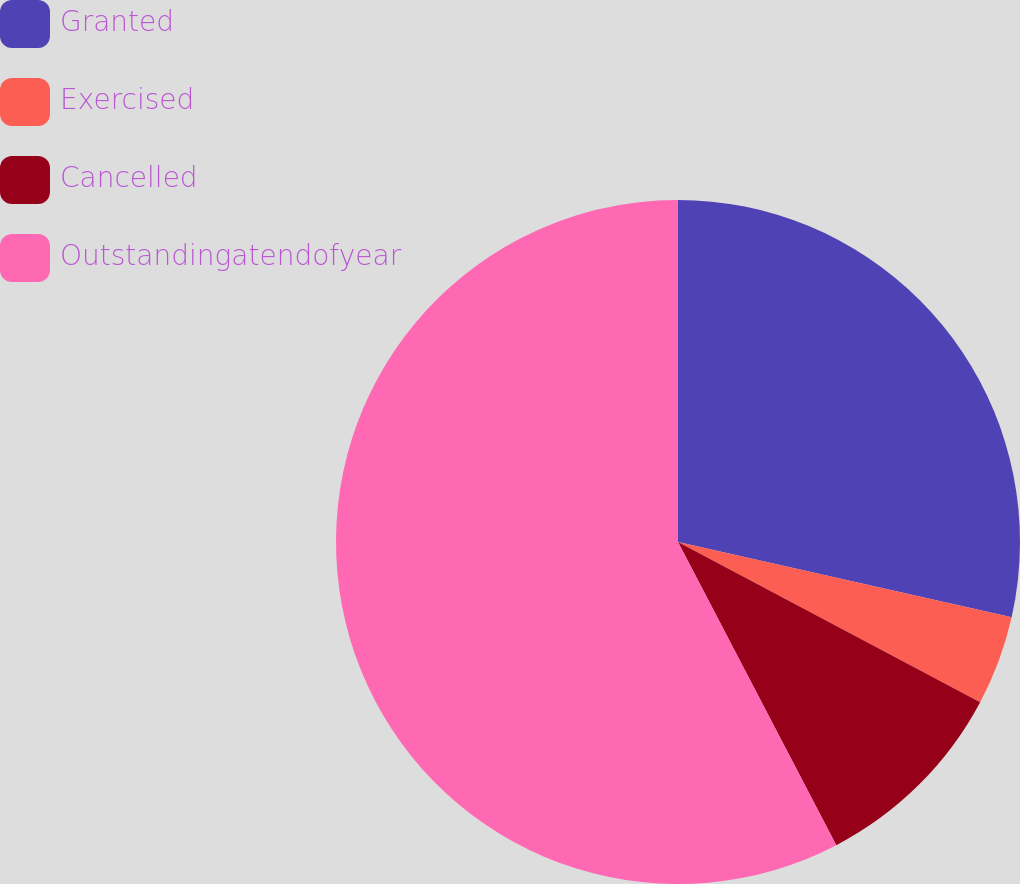Convert chart to OTSL. <chart><loc_0><loc_0><loc_500><loc_500><pie_chart><fcel>Granted<fcel>Exercised<fcel>Cancelled<fcel>Outstandingatendofyear<nl><fcel>28.53%<fcel>4.23%<fcel>9.58%<fcel>57.66%<nl></chart> 